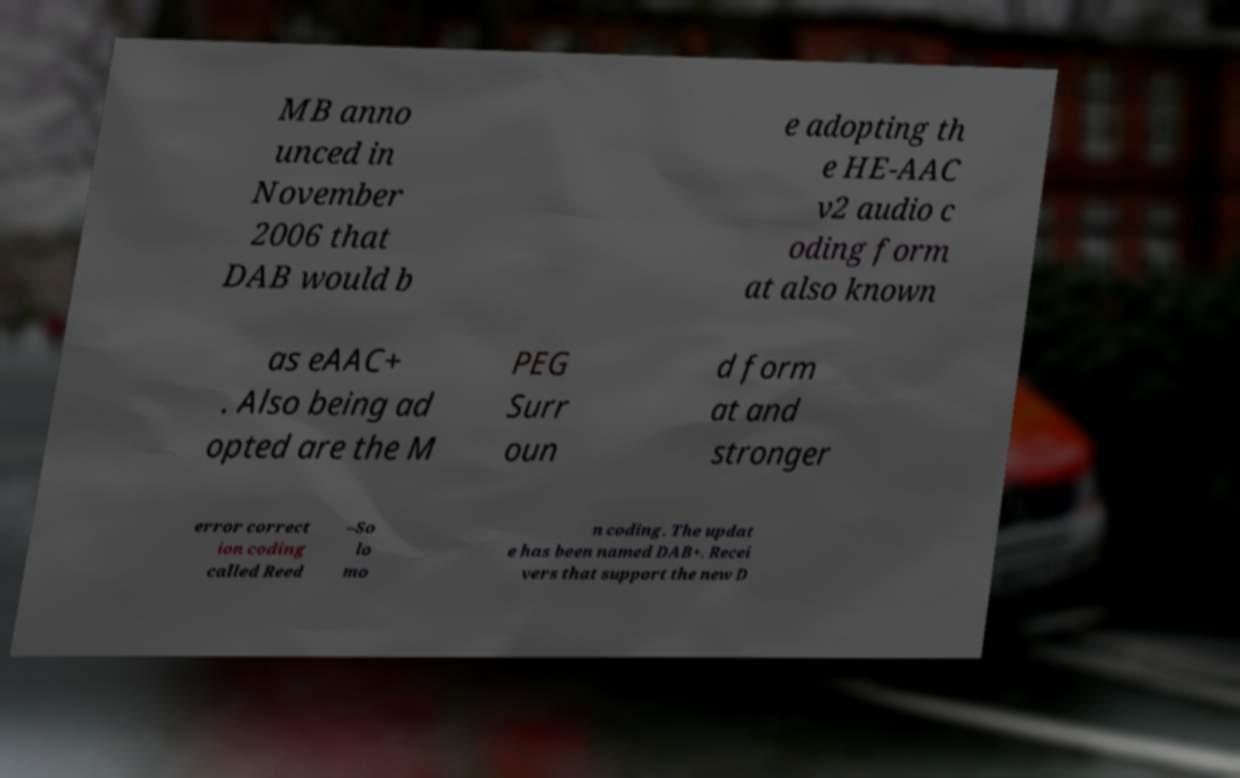There's text embedded in this image that I need extracted. Can you transcribe it verbatim? MB anno unced in November 2006 that DAB would b e adopting th e HE-AAC v2 audio c oding form at also known as eAAC+ . Also being ad opted are the M PEG Surr oun d form at and stronger error correct ion coding called Reed –So lo mo n coding. The updat e has been named DAB+. Recei vers that support the new D 